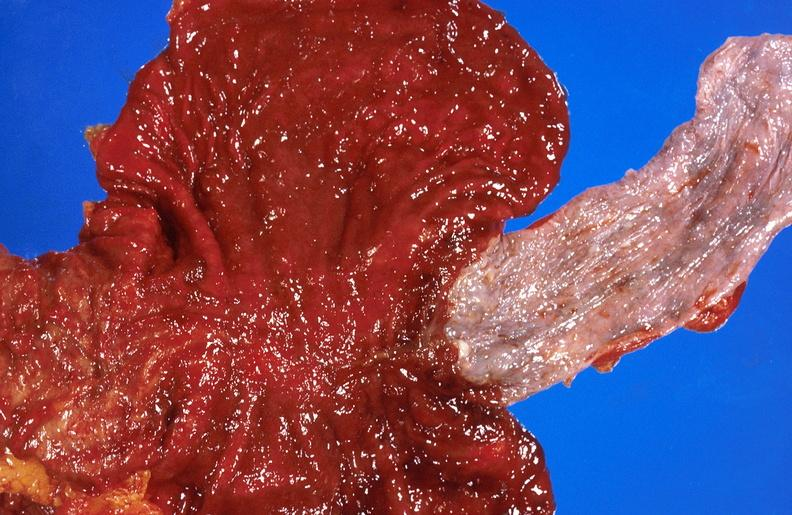does infiltrative process show alcoholic cirrhosis?
Answer the question using a single word or phrase. No 